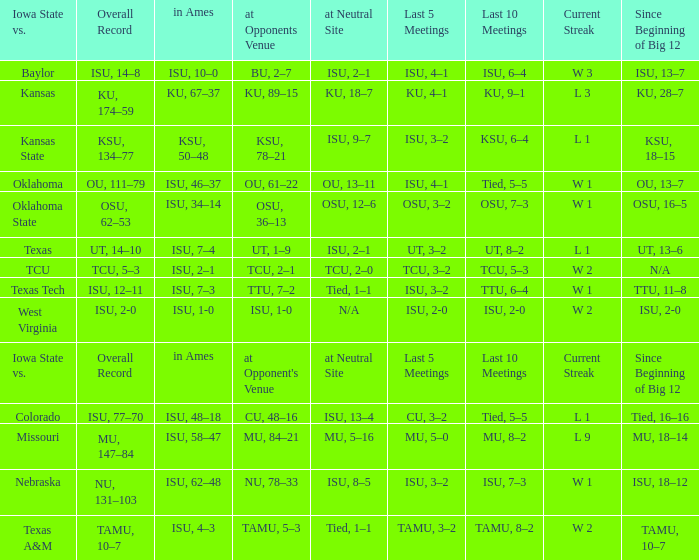When the value of "since beginning of big 12" is synonymous with its' category, what are the in Ames values? In ames. 